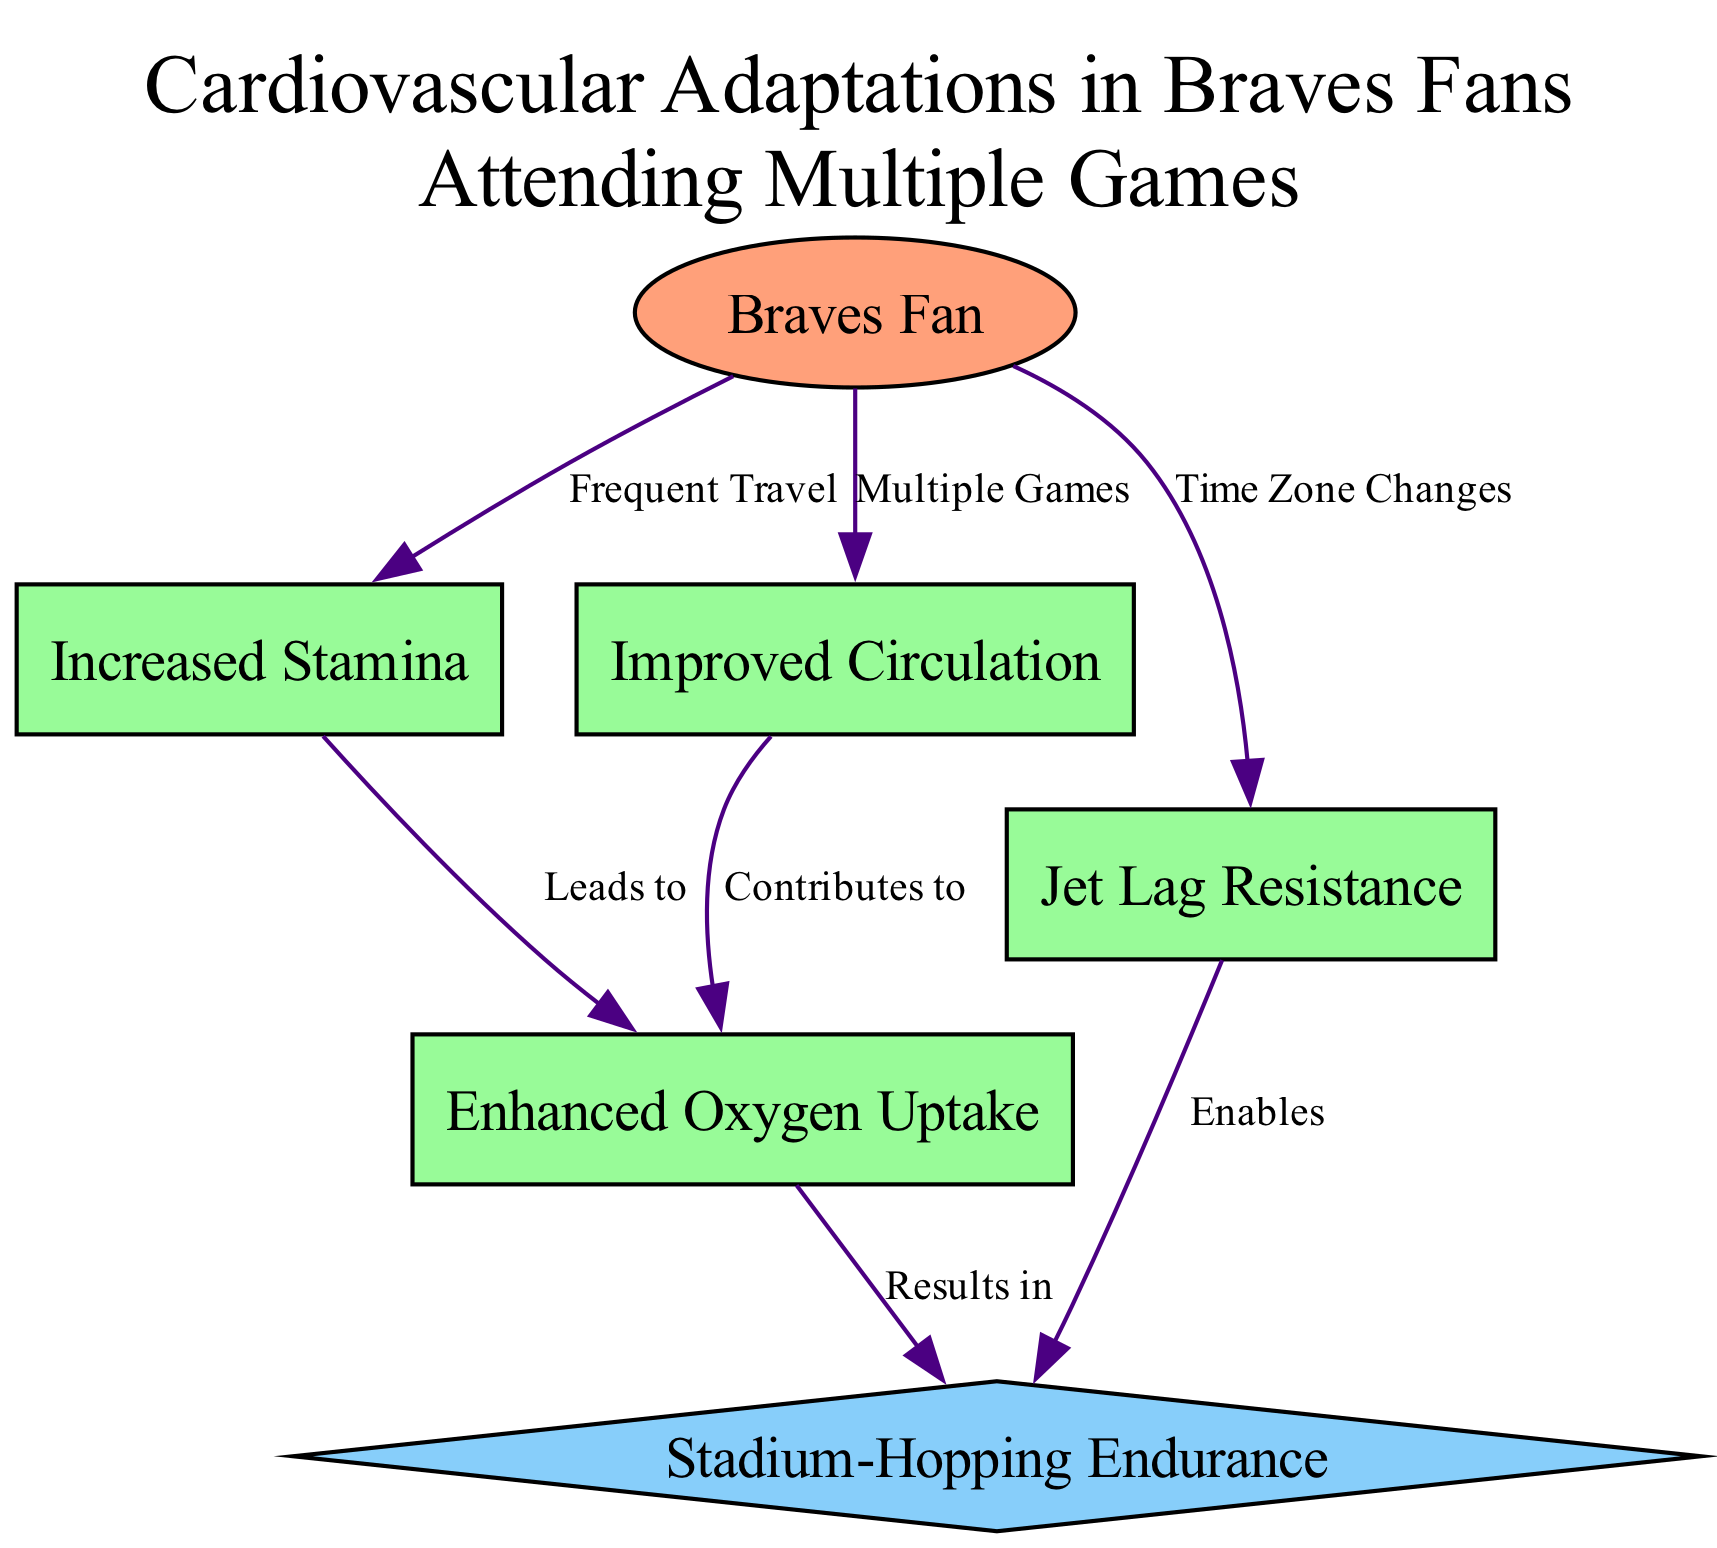What is the starting point in the diagram? The starting point in the diagram is indicated by the node labeled "Braves Fan," which represents the initial subject of the diagram.
Answer: Braves Fan How many adaptations are listed in the diagram? By counting the nodes marked as "Adaptation," we see there are four: Increased Stamina, Improved Circulation, Jet Lag Resistance, and Enhanced Oxygen Uptake.
Answer: 4 What relationship connects "Braves Fan" to "Improved Circulation"? The relationship is labeled "Multiple Games," indicating that attending multiple games contributes to improved circulation for the fan.
Answer: Multiple Games Which adaptation leads to enhanced oxygen uptake? The adaptation that leads to Enhanced Oxygen Uptake is Increased Stamina, as shown by the directed edge from Increased Stamina to Enhanced Oxygen Uptake marked "Leads to."
Answer: Increased Stamina What outcome is enabled by jet lag resistance? The outcome enabled by Jet Lag Resistance is "Stadium-Hopping Endurance," which signifies the ability to endure traveling to various stadiums without the hindrance of jet lag.
Answer: Stadium-Hopping Endurance Which adaptation results in stadium-hopping endurance? The adaptation that results in Stadium-Hopping Endurance is Enhanced Oxygen Uptake, as shown by the directed edge from Enhanced Oxygen Uptake marked "Results in."
Answer: Enhanced Oxygen Uptake How many edges are depicted in the diagram? The number of edges can be counted, showing that there are six edges connecting various nodes in the diagram, each illustrating relationships between different aspects of the adaptations.
Answer: 6 What adaptation is directly related to time zone changes? The adaptation directly related to Time Zone Changes is Jet Lag Resistance, as represented by the edge connecting the node "Braves Fan" to "Jet Lag Resistance" labeled "Time Zone Changes."
Answer: Jet Lag Resistance What is the final outcome in the adaptation process for long-distance travelers? The final outcome in the adaptation process is "Stadium-Hopping Endurance," indicating the capability to travel extensively to different games without significant fatigue.
Answer: Stadium-Hopping Endurance 